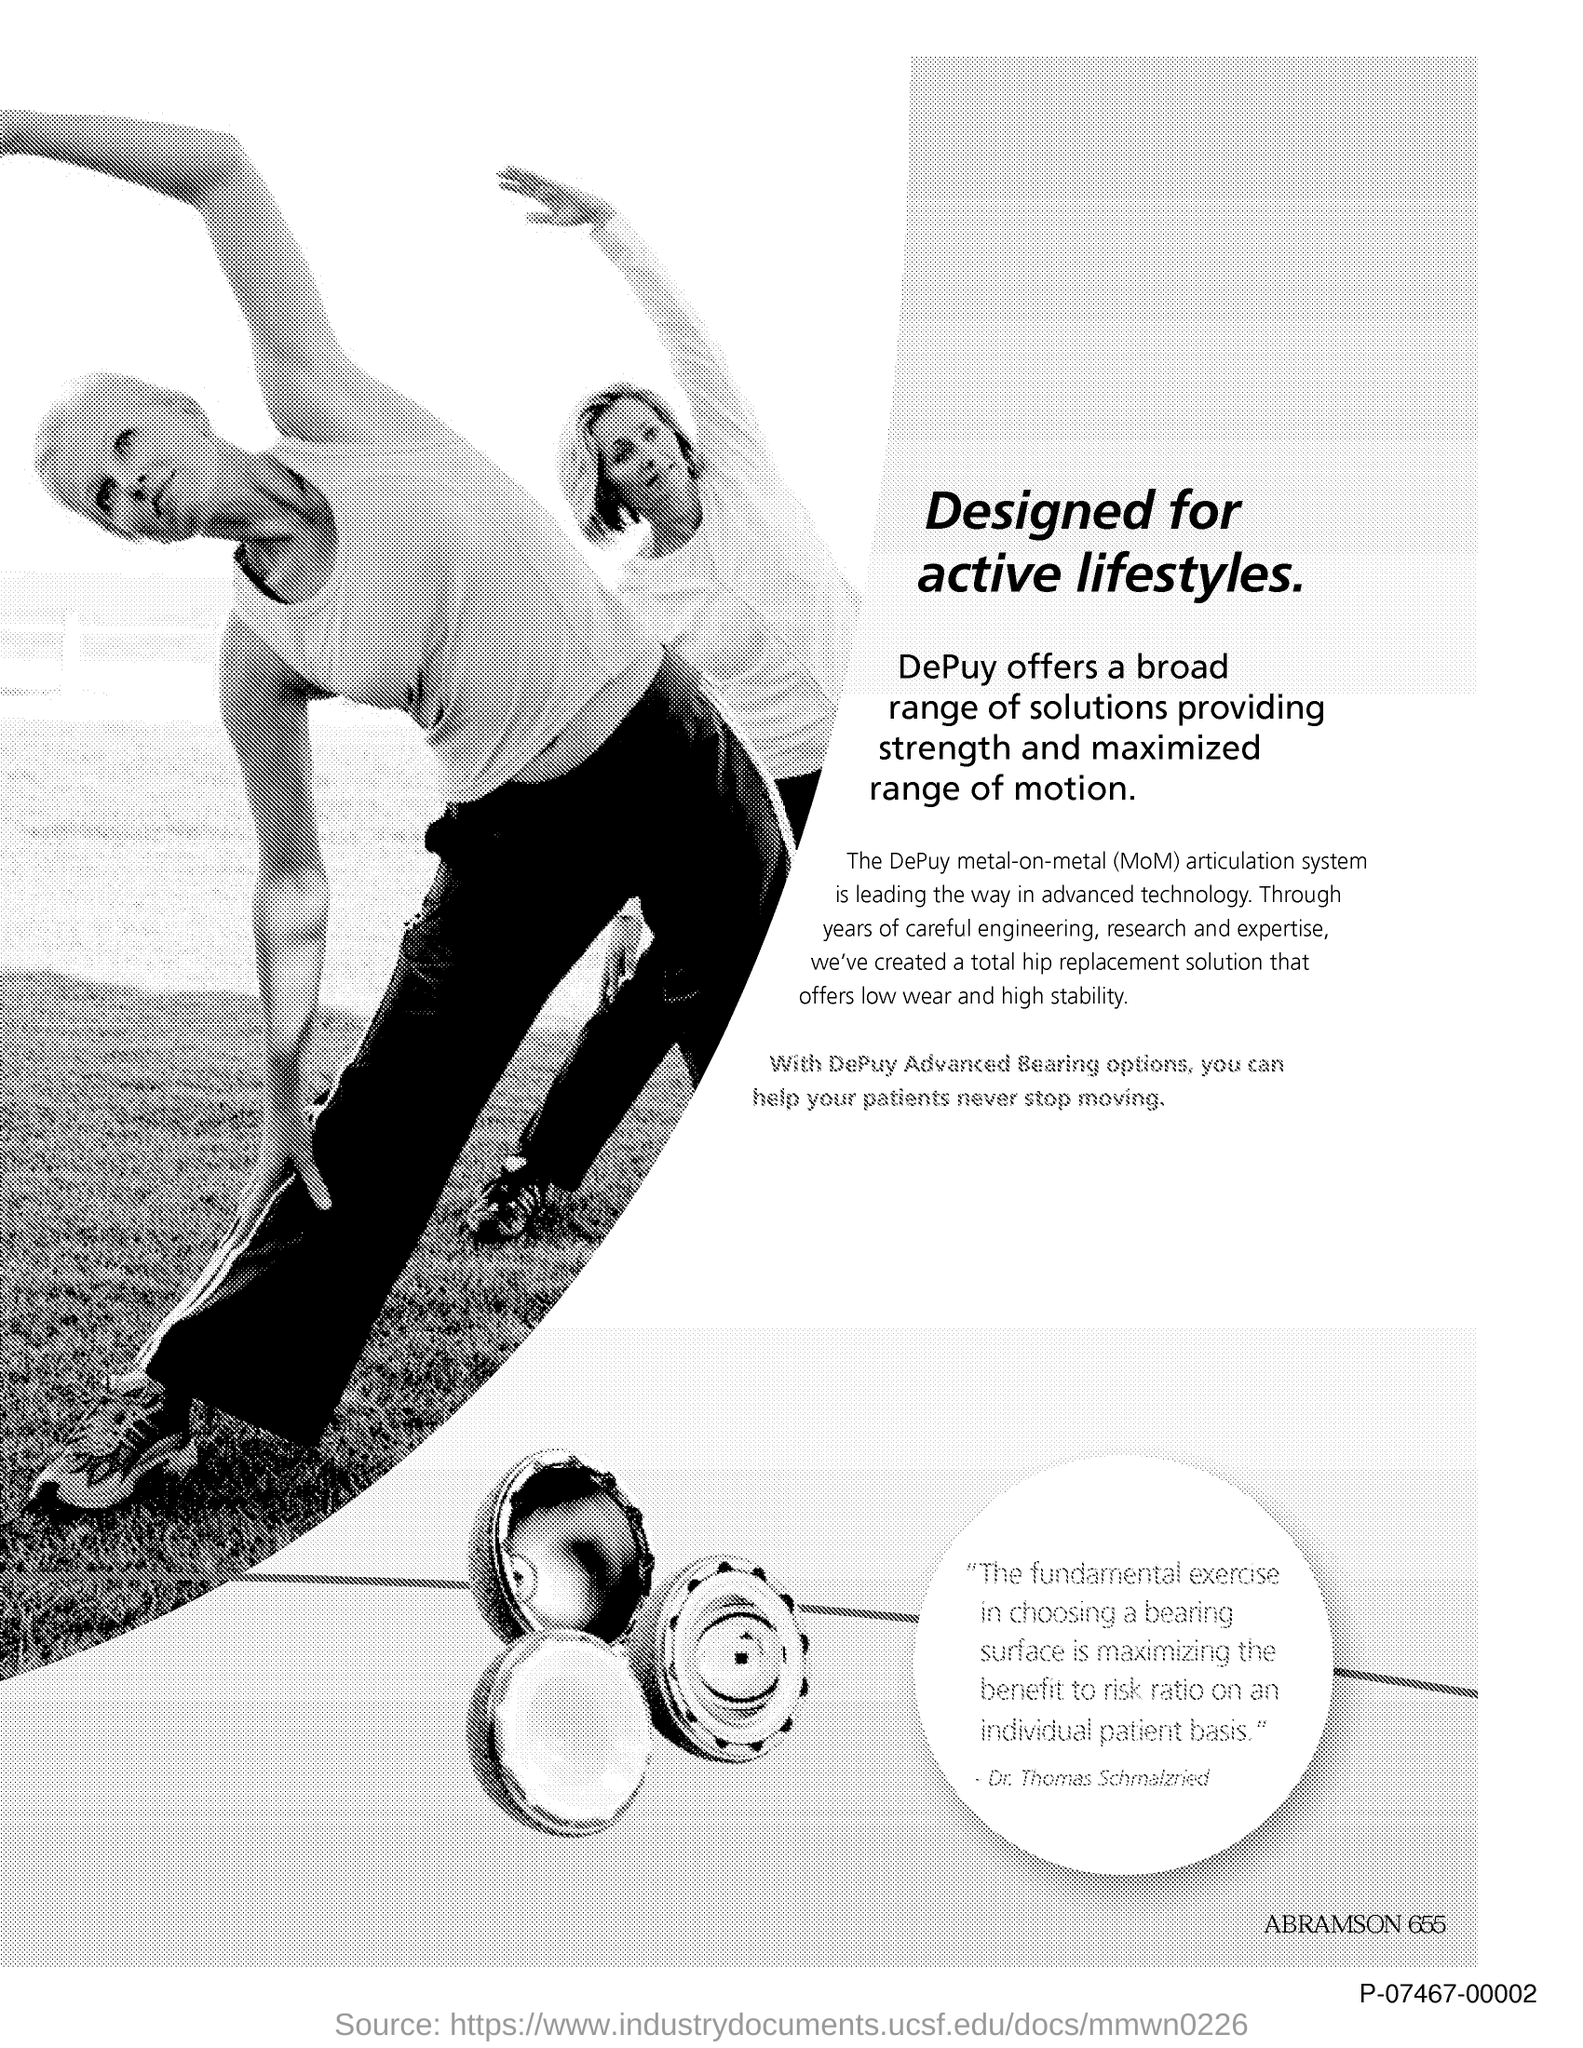Specify some key components in this picture. The document's title is "Designed for Active Lifestyles. 